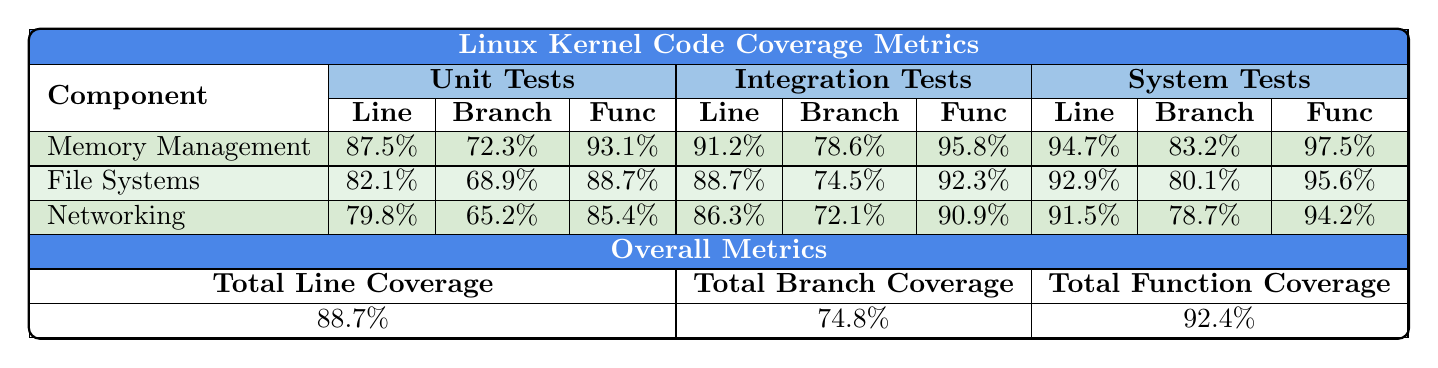What is the Line Coverage for the Memory Management component in System Tests? In the table, the Line Coverage for Memory Management under System Tests is listed as 94.7%.
Answer: 94.7% What is the Branch Coverage percentage for File Systems in Unit Tests? According to the table, the Branch Coverage for File Systems in Unit Tests is 68.9%.
Answer: 68.9% Which test suite has the highest Function Coverage for the Networking component? By comparing the Function Coverage values for Networking across all test suites, System Tests has the highest at 94.2%.
Answer: System Tests What is the difference in Line Coverage between Integration Tests and Unit Tests for the Memory Management component? To find the difference, we subtract the Line Coverage of Unit Tests (87.5%) from Integration Tests (91.2%), resulting in a difference of 3.7%.
Answer: 3.7% Does the File Systems component have a higher Line Coverage in System Tests than in Unit Tests? By comparing the Line Coverage values from the table, File Systems has 92.9% in System Tests and 82.1% in Unit Tests, confirming that System Tests is higher.
Answer: Yes What is the average Function Coverage across all components in Unit Tests? To calculate the average Function Coverage for Unit Tests, we add the Function Coverage values (93.1% + 88.7% + 85.4%) and divide by 3, giving us an average of 89.57%.
Answer: 89.57% Which component has the lowest Branch Coverage in Integration Tests? Reviewing the Branch Coverage values for all components in Integration Tests, Networking has the lowest value at 72.1%.
Answer: Networking What is the total Function Coverage across all test suites? The total Function Coverage is found in the Overall Metrics as 92.4%.
Answer: 92.4% How does the Memory Management component's Branch Coverage in System Tests compare to its Branch Coverage in Integration Tests? The Branch Coverage for Memory Management in System Tests is 83.2%, and in Integration Tests, it is 78.6%. Thus, System Tests has a higher Branch Coverage.
Answer: Higher in System Tests What is the overall average Branch Coverage for all components across all test suites? To find the overall average, we sum the total branch coverages (72.3% + 78.6% + 83.2% + 68.9% + 74.5% + 80.1% + 65.2% + 72.1% + 78.7%) and divide by 9, resulting in an average of 74.8%.
Answer: 74.8% 